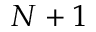Convert formula to latex. <formula><loc_0><loc_0><loc_500><loc_500>N + 1</formula> 